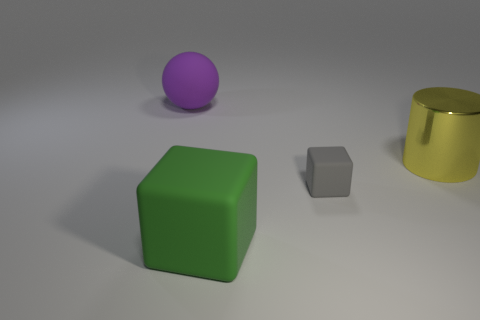There is a block that is behind the big matte thing on the right side of the big purple rubber object; are there any cubes to the left of it? Yes, there is a single cube to the left of the large purple sphere, positioned slightly behind the green cube and in front of the matte gold cylinder. 